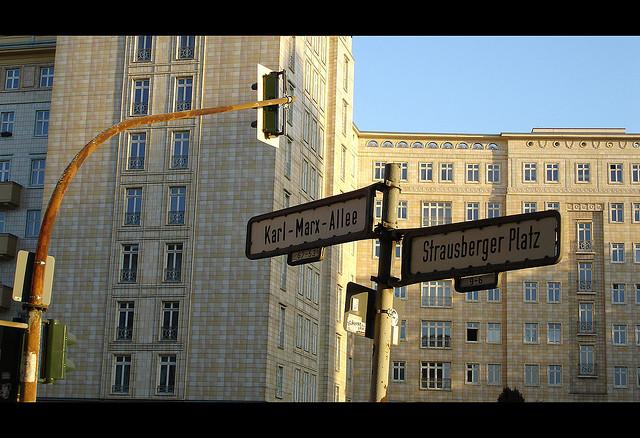Does the sky have clouds in it?
Keep it brief. No. Do you see a clock?
Concise answer only. No. What color are the bricks?
Answer briefly. Brown. What does the black and white sign say?
Quick response, please. Karl-marx-allee. Is this Manhattan?
Concise answer only. No. Do you see 12 windows on the front of one building?
Short answer required. Yes. How many floors does the building have?
Answer briefly. 7. Are the labels on the street?
Answer briefly. Yes. Does this street have a name?
Write a very short answer. Yes. What does the sign on the right say?
Write a very short answer. Strausberger platz. What is Boulevard name?
Keep it brief. Strausberger platz. What is the name of the street?
Quick response, please. Strausberger platz. What does the sign on the left say?
Quick response, please. Karl marx allee. Where is the pattern that looks like a ladder?
Short answer required. On building. Where is a banner with Pivot on it?
Be succinct. Nowhere. Is this in China?
Short answer required. No. 